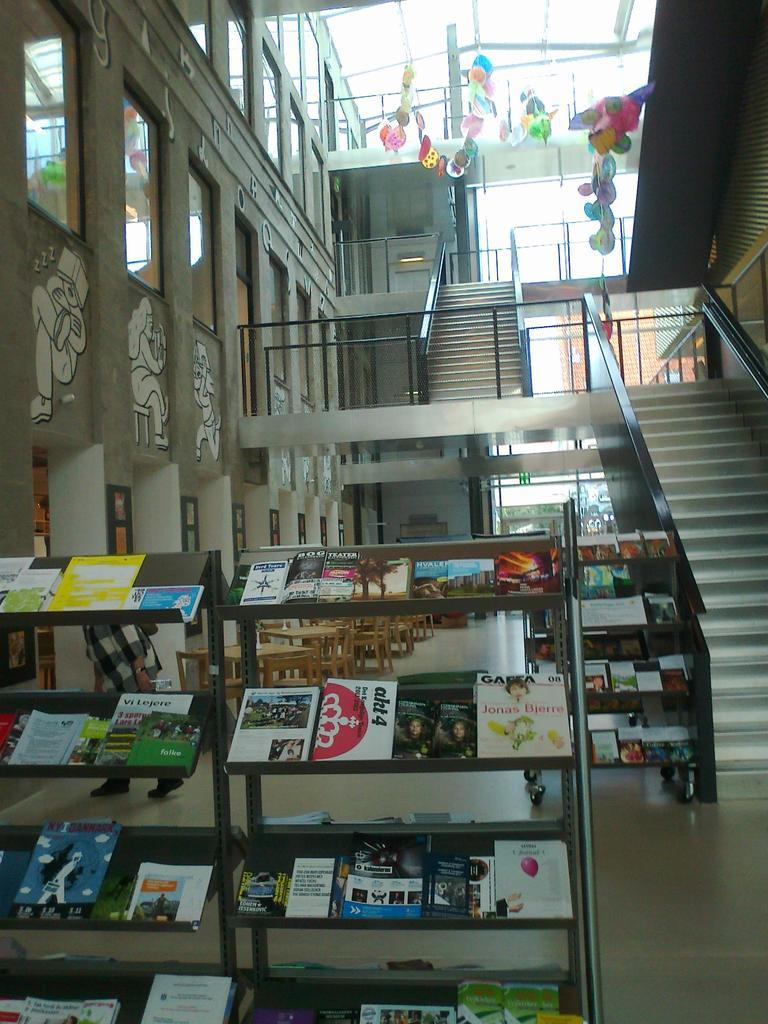What type of structure can be seen in the image? There is a wall in the image. Are there any window treatments visible in the image? Yes, there are curtains in the image. What architectural feature is present in the image? There are stairs in the image. What can be found on the rack in the image? The rack is filled with books in the image. What type of operation is being performed on the pigs in the image? There are no pigs present in the image, and therefore no operation is being performed. 